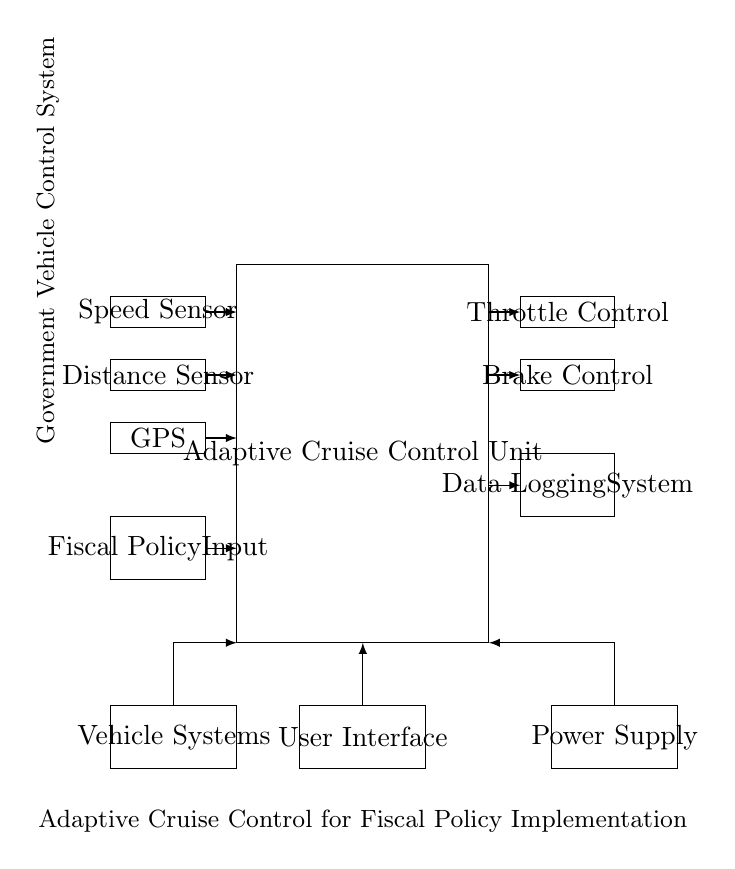What is the main control unit of the circuit? The main control unit is labeled as "Adaptive Cruise Control Unit," which indicates its primary function in the system.
Answer: Adaptive Cruise Control Unit How many sensors are present in the circuit? There are three sensors shown (speed sensor, distance sensor, GPS), indicating the inputs the system uses to make driving decisions.
Answer: Three What is the function of the fiscal policy input? The fiscal policy input serves as a means to integrate government regulations or guidelines into the vehicle’s operational control, influencing its behavior based on external policies.
Answer: Input to adapt to fiscal policy What are the two types of actuators in the circuit? The actuators are "Throttle Control" and "Brake Control," which are responsible for adjusting the vehicle's speed and stopping based on signals from the control unit.
Answer: Throttle and Brake Describe the relationship between the user interface and the main control unit. The user interface allows for interaction with the control unit, enabling adjustments and settings input by the operator, indicating a user-controlled feedback loop in the system.
Answer: Interaction loop How does the data logging system contribute to the overall function of the adaptive cruise control circuit? The data logging system captures and stores data regarding the vehicle's operation and the external conditions affecting it, allowing for assessment of policy effectiveness and potential system improvements over time.
Answer: Records operational data What is the role of the power supply in this circuit? The power supply provides the necessary electrical power to all components within the circuit, ensuring that the adaptive cruise control unit and its associated sensors and actuators operate effectively.
Answer: Powers the circuit 